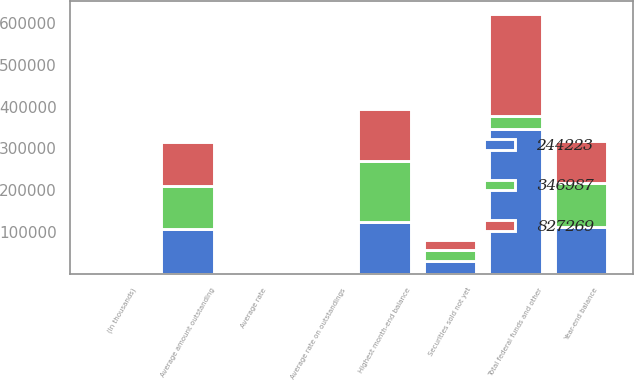Convert chart to OTSL. <chart><loc_0><loc_0><loc_500><loc_500><stacked_bar_chart><ecel><fcel>(In thousands)<fcel>Average amount outstanding<fcel>Average rate<fcel>Highest month-end balance<fcel>Year-end balance<fcel>Average rate on outstandings<fcel>Securities sold not yet<fcel>Total federal funds and other<nl><fcel>346987<fcel>2016<fcel>104866<fcel>0.29<fcel>147900<fcel>105563<fcel>0.51<fcel>25321<fcel>30158<nl><fcel>244223<fcel>2015<fcel>105910<fcel>0.18<fcel>122461<fcel>111263<fcel>0.25<fcel>30158<fcel>346987<nl><fcel>827269<fcel>2014<fcel>104358<fcel>0.17<fcel>124093<fcel>100193<fcel>0.15<fcel>24230<fcel>244223<nl></chart> 